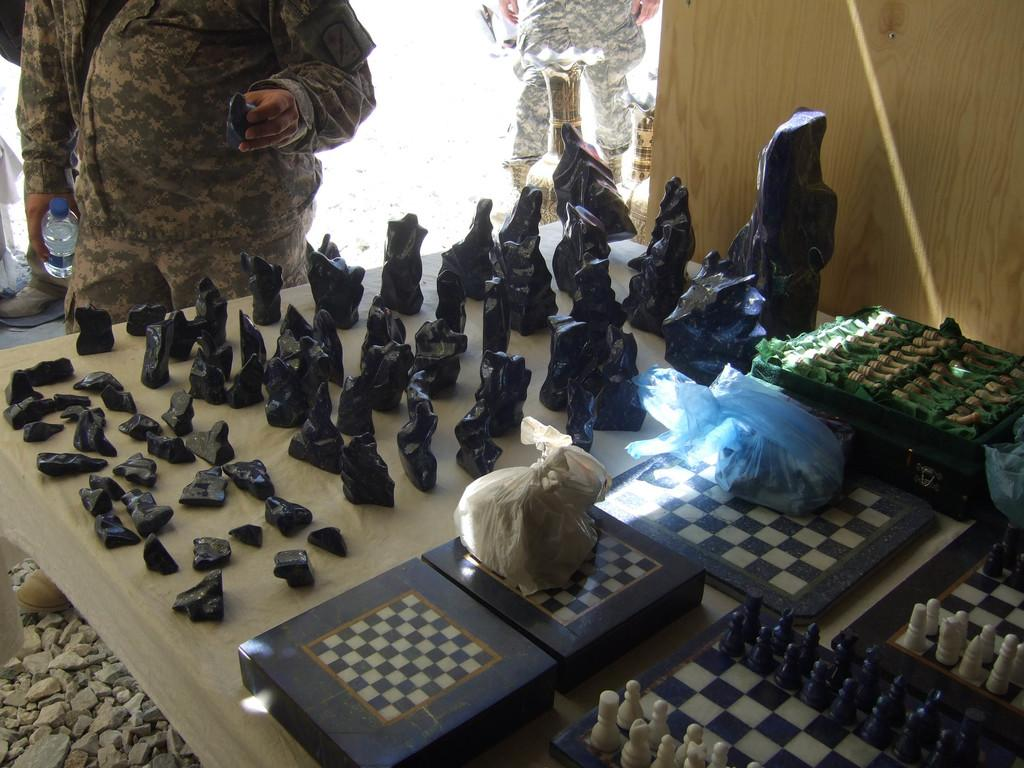What is the main object on the table in the image? There are different sizes of stones on the table. What else can be seen on the table besides the stones? There are chess boards and chess coins on the table. Are there any protective covers on the table? Yes, there are polythene covers on the table. Are there any people present in the image? Yes, there are persons standing beside the table. What type of prose can be heard being recited by the dog in the image? There is no dog present in the image, and therefore no prose can be heard being recited. 